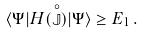Convert formula to latex. <formula><loc_0><loc_0><loc_500><loc_500>\langle \Psi | H ( \stackrel { \circ } { \mathbb { J } } ) | \Psi \rangle \geq E _ { 1 } \, .</formula> 